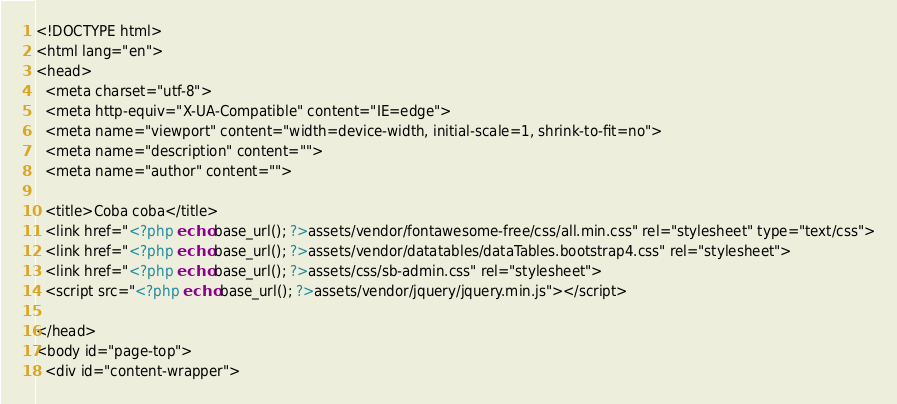<code> <loc_0><loc_0><loc_500><loc_500><_PHP_><!DOCTYPE html>
<html lang="en">
<head>
  <meta charset="utf-8">
  <meta http-equiv="X-UA-Compatible" content="IE=edge">
  <meta name="viewport" content="width=device-width, initial-scale=1, shrink-to-fit=no">
  <meta name="description" content="">
  <meta name="author" content="">

  <title>Coba coba</title>
  <link href="<?php echo base_url(); ?>assets/vendor/fontawesome-free/css/all.min.css" rel="stylesheet" type="text/css">
  <link href="<?php echo base_url(); ?>assets/vendor/datatables/dataTables.bootstrap4.css" rel="stylesheet">    
  <link href="<?php echo base_url(); ?>assets/css/sb-admin.css" rel="stylesheet">
  <script src="<?php echo base_url(); ?>assets/vendor/jquery/jquery.min.js"></script>
  
</head>
<body id="page-top">
  <div id="content-wrapper"></code> 